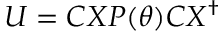Convert formula to latex. <formula><loc_0><loc_0><loc_500><loc_500>U = C X P ( \theta ) C X ^ { \dagger }</formula> 